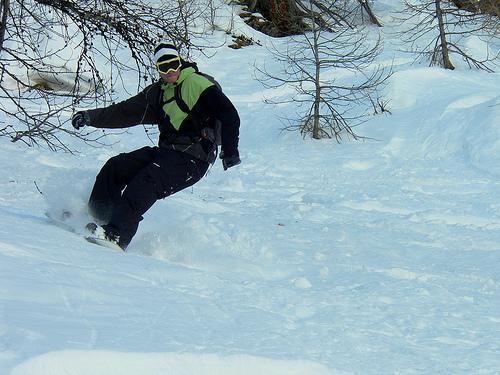How many people in the photo?
Give a very brief answer. 1. 